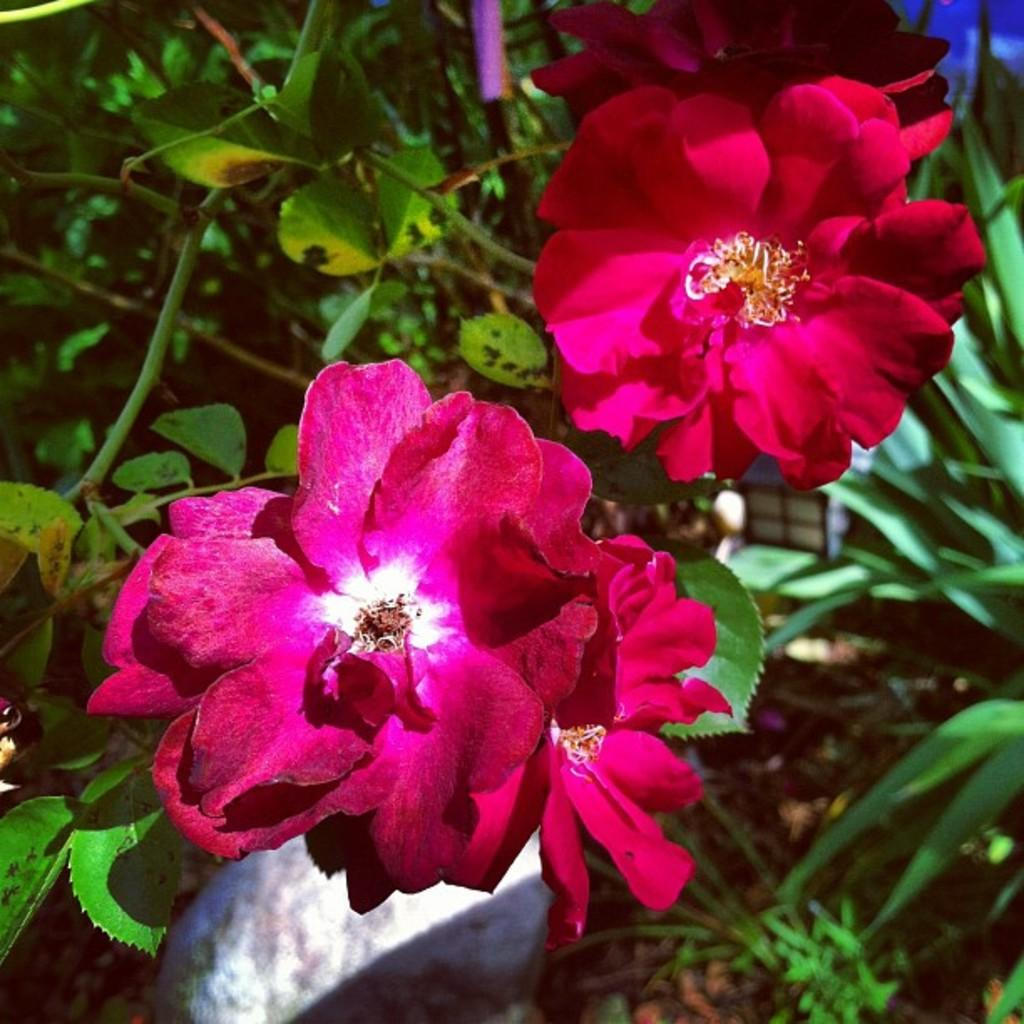What type of vegetation is visible in the front of the image? There are flowers in the front of the image. What can be seen in the background of the image? There are leaves in the background of the image. What type of cheese is present in the image? There is no cheese present in the image. What is the size of the screw visible in the image? There is no screw present in the image. 